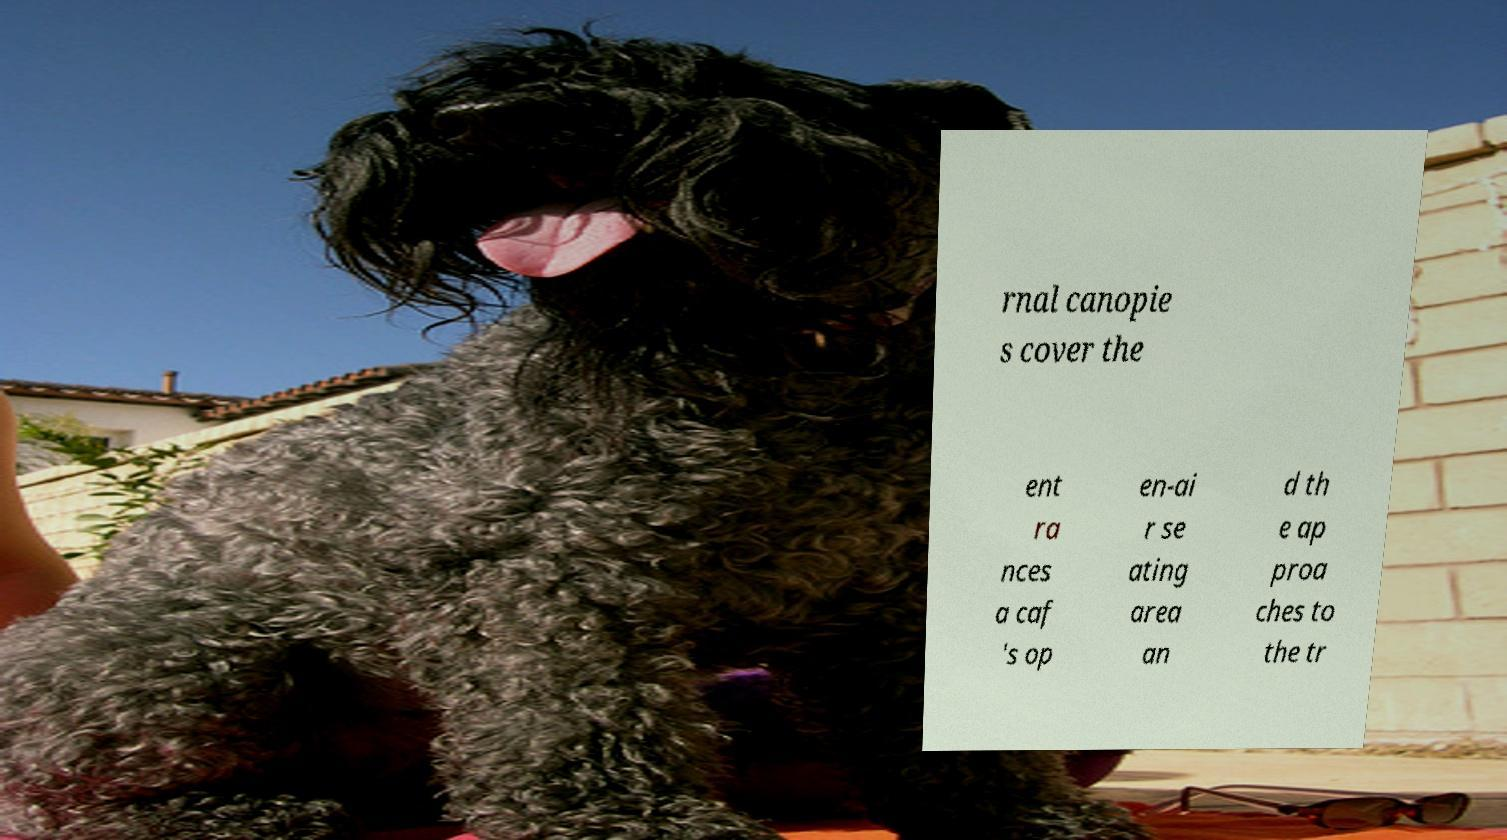What messages or text are displayed in this image? I need them in a readable, typed format. rnal canopie s cover the ent ra nces a caf 's op en-ai r se ating area an d th e ap proa ches to the tr 